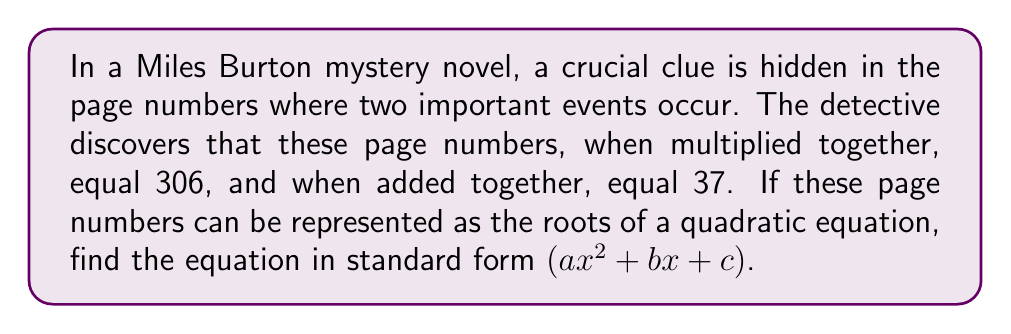Solve this math problem. Let's approach this step-by-step:

1) Let the two page numbers be $p$ and $q$. We know:
   $p \times q = 306$
   $p + q = 37$

2) In a quadratic equation $ax^2 + bx + c = 0$, if $p$ and $q$ are the roots, then:
   $p + q = -\frac{b}{a}$
   $p \times q = \frac{c}{a}$

3) From this, we can deduce:
   $-\frac{b}{a} = 37$
   $\frac{c}{a} = 306$

4) To simplify, let's assume $a = 1$. Then:
   $b = -37$
   $c = 306$

5) Therefore, the quadratic equation in standard form is:
   $x^2 - 37x + 306 = 0$

6) To verify, we can use the quadratic formula to find the roots:
   $x = \frac{-b \pm \sqrt{b^2 - 4ac}}{2a}$

   $x = \frac{37 \pm \sqrt{37^2 - 4(1)(306)}}{2(1)}$

   $x = \frac{37 \pm \sqrt{1369 - 1224}}{2}$

   $x = \frac{37 \pm \sqrt{145}}{2}$

   $x = \frac{37 \pm 12.0415}{2}$

7) This gives us:
   $x_1 = \frac{37 + 12.0415}{2} = 24.52075$
   $x_2 = \frac{37 - 12.0415}{2} = 12.47925$

8) Rounding to whole numbers (as page numbers), we get 25 and 12, which indeed multiply to 300 and add to 37.
Answer: $x^2 - 37x + 306 = 0$ 